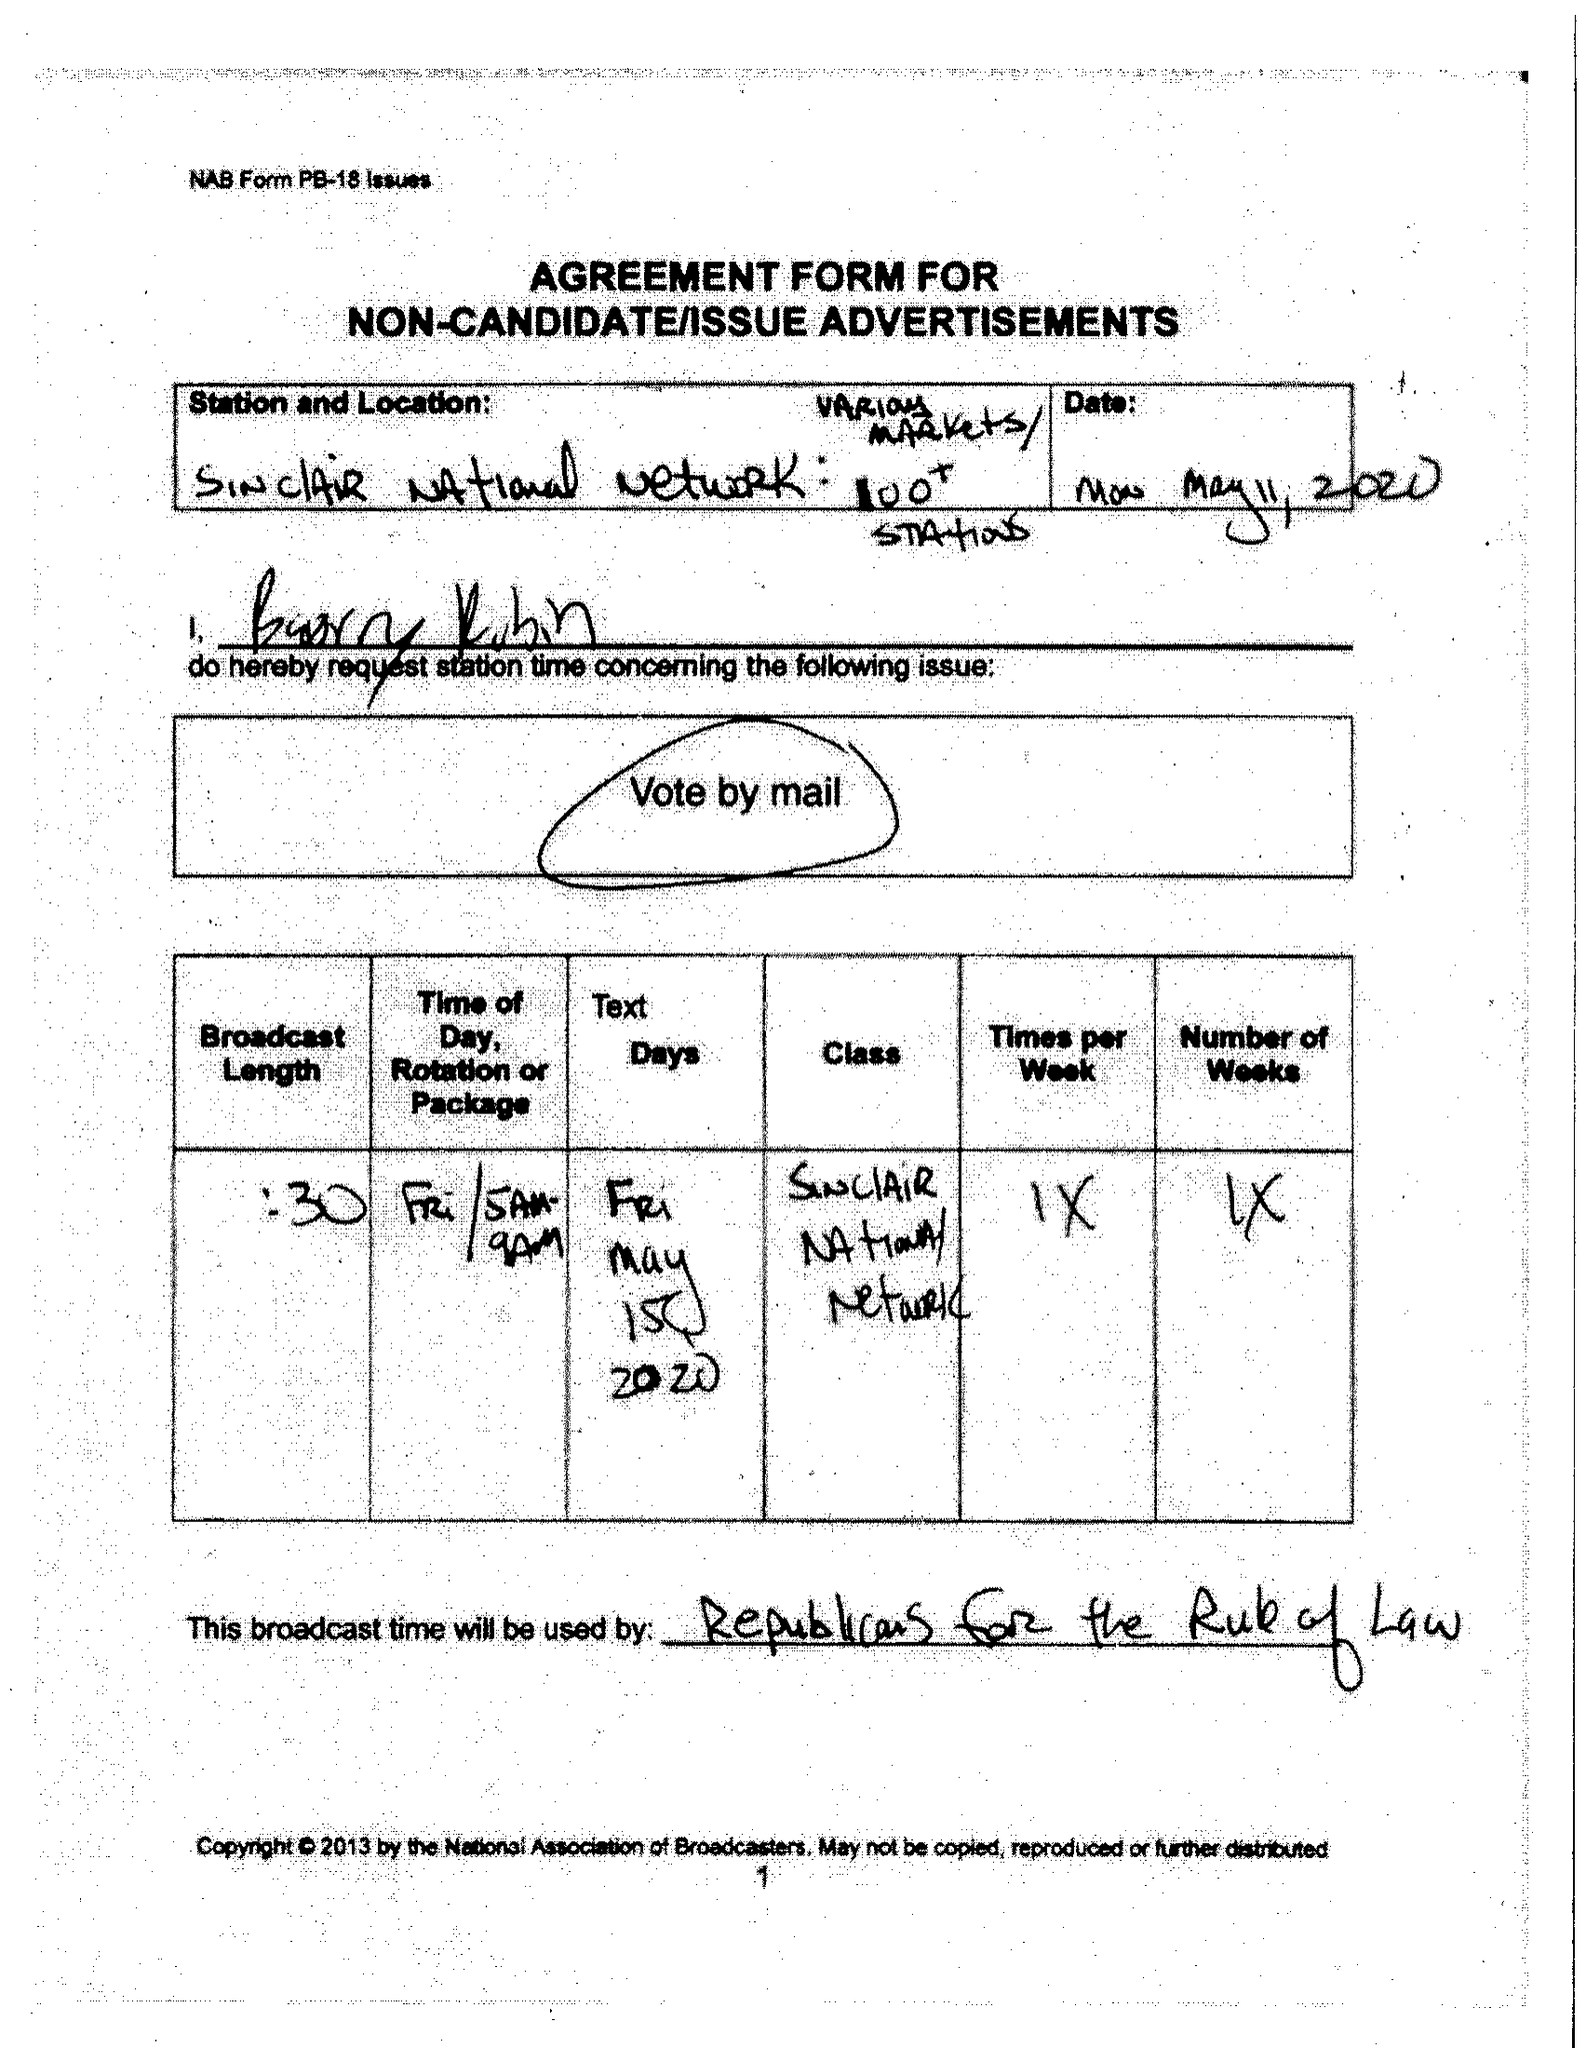What is the value for the advertiser?
Answer the question using a single word or phrase. None 